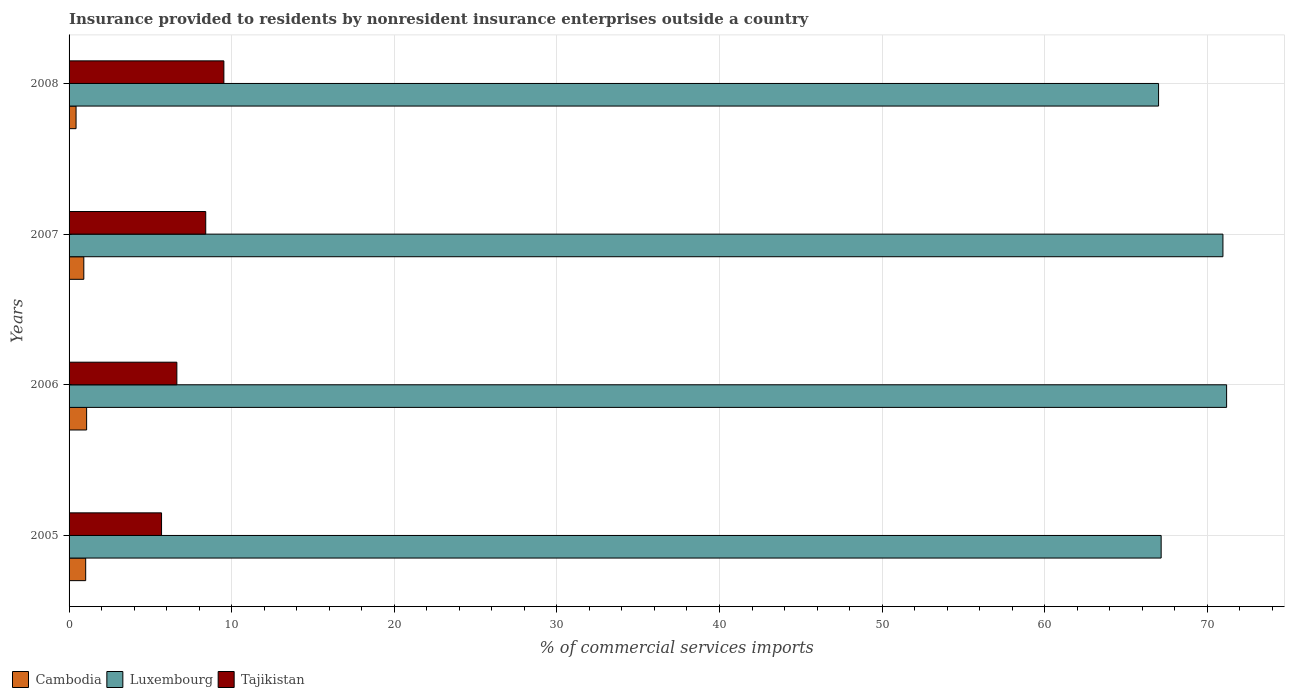How many groups of bars are there?
Your answer should be very brief. 4. Are the number of bars per tick equal to the number of legend labels?
Your response must be concise. Yes. Are the number of bars on each tick of the Y-axis equal?
Your answer should be very brief. Yes. How many bars are there on the 3rd tick from the top?
Offer a very short reply. 3. In how many cases, is the number of bars for a given year not equal to the number of legend labels?
Your response must be concise. 0. What is the Insurance provided to residents in Cambodia in 2005?
Offer a very short reply. 1.02. Across all years, what is the maximum Insurance provided to residents in Cambodia?
Your answer should be very brief. 1.08. Across all years, what is the minimum Insurance provided to residents in Cambodia?
Provide a short and direct response. 0.43. In which year was the Insurance provided to residents in Cambodia maximum?
Keep it short and to the point. 2006. What is the total Insurance provided to residents in Luxembourg in the graph?
Provide a short and direct response. 276.3. What is the difference between the Insurance provided to residents in Luxembourg in 2005 and that in 2007?
Keep it short and to the point. -3.8. What is the difference between the Insurance provided to residents in Luxembourg in 2005 and the Insurance provided to residents in Tajikistan in 2008?
Offer a terse response. 57.64. What is the average Insurance provided to residents in Luxembourg per year?
Provide a short and direct response. 69.08. In the year 2005, what is the difference between the Insurance provided to residents in Tajikistan and Insurance provided to residents in Cambodia?
Make the answer very short. 4.66. In how many years, is the Insurance provided to residents in Cambodia greater than 22 %?
Your answer should be very brief. 0. What is the ratio of the Insurance provided to residents in Tajikistan in 2007 to that in 2008?
Your answer should be very brief. 0.88. Is the Insurance provided to residents in Tajikistan in 2005 less than that in 2008?
Offer a terse response. Yes. What is the difference between the highest and the second highest Insurance provided to residents in Luxembourg?
Offer a terse response. 0.23. What is the difference between the highest and the lowest Insurance provided to residents in Tajikistan?
Make the answer very short. 3.83. In how many years, is the Insurance provided to residents in Cambodia greater than the average Insurance provided to residents in Cambodia taken over all years?
Keep it short and to the point. 3. What does the 2nd bar from the top in 2006 represents?
Your answer should be compact. Luxembourg. What does the 2nd bar from the bottom in 2006 represents?
Your response must be concise. Luxembourg. Is it the case that in every year, the sum of the Insurance provided to residents in Cambodia and Insurance provided to residents in Tajikistan is greater than the Insurance provided to residents in Luxembourg?
Make the answer very short. No. Are all the bars in the graph horizontal?
Offer a very short reply. Yes. Does the graph contain any zero values?
Give a very brief answer. No. Does the graph contain grids?
Your response must be concise. Yes. How many legend labels are there?
Provide a short and direct response. 3. How are the legend labels stacked?
Offer a terse response. Horizontal. What is the title of the graph?
Give a very brief answer. Insurance provided to residents by nonresident insurance enterprises outside a country. Does "El Salvador" appear as one of the legend labels in the graph?
Keep it short and to the point. No. What is the label or title of the X-axis?
Offer a very short reply. % of commercial services imports. What is the label or title of the Y-axis?
Keep it short and to the point. Years. What is the % of commercial services imports of Cambodia in 2005?
Give a very brief answer. 1.02. What is the % of commercial services imports of Luxembourg in 2005?
Ensure brevity in your answer.  67.16. What is the % of commercial services imports of Tajikistan in 2005?
Your answer should be compact. 5.69. What is the % of commercial services imports of Cambodia in 2006?
Provide a succinct answer. 1.08. What is the % of commercial services imports of Luxembourg in 2006?
Offer a very short reply. 71.19. What is the % of commercial services imports in Tajikistan in 2006?
Offer a very short reply. 6.63. What is the % of commercial services imports of Cambodia in 2007?
Keep it short and to the point. 0.91. What is the % of commercial services imports in Luxembourg in 2007?
Offer a terse response. 70.96. What is the % of commercial services imports of Tajikistan in 2007?
Provide a succinct answer. 8.4. What is the % of commercial services imports in Cambodia in 2008?
Offer a terse response. 0.43. What is the % of commercial services imports of Luxembourg in 2008?
Provide a succinct answer. 67. What is the % of commercial services imports in Tajikistan in 2008?
Keep it short and to the point. 9.52. Across all years, what is the maximum % of commercial services imports of Cambodia?
Give a very brief answer. 1.08. Across all years, what is the maximum % of commercial services imports of Luxembourg?
Provide a succinct answer. 71.19. Across all years, what is the maximum % of commercial services imports of Tajikistan?
Your response must be concise. 9.52. Across all years, what is the minimum % of commercial services imports in Cambodia?
Offer a very short reply. 0.43. Across all years, what is the minimum % of commercial services imports in Luxembourg?
Provide a succinct answer. 67. Across all years, what is the minimum % of commercial services imports in Tajikistan?
Provide a short and direct response. 5.69. What is the total % of commercial services imports of Cambodia in the graph?
Keep it short and to the point. 3.44. What is the total % of commercial services imports in Luxembourg in the graph?
Give a very brief answer. 276.3. What is the total % of commercial services imports of Tajikistan in the graph?
Your response must be concise. 30.24. What is the difference between the % of commercial services imports of Cambodia in 2005 and that in 2006?
Your answer should be very brief. -0.06. What is the difference between the % of commercial services imports of Luxembourg in 2005 and that in 2006?
Offer a terse response. -4.03. What is the difference between the % of commercial services imports in Tajikistan in 2005 and that in 2006?
Offer a terse response. -0.94. What is the difference between the % of commercial services imports of Cambodia in 2005 and that in 2007?
Ensure brevity in your answer.  0.12. What is the difference between the % of commercial services imports in Luxembourg in 2005 and that in 2007?
Keep it short and to the point. -3.8. What is the difference between the % of commercial services imports in Tajikistan in 2005 and that in 2007?
Ensure brevity in your answer.  -2.72. What is the difference between the % of commercial services imports of Cambodia in 2005 and that in 2008?
Give a very brief answer. 0.59. What is the difference between the % of commercial services imports of Luxembourg in 2005 and that in 2008?
Your response must be concise. 0.16. What is the difference between the % of commercial services imports in Tajikistan in 2005 and that in 2008?
Give a very brief answer. -3.83. What is the difference between the % of commercial services imports of Cambodia in 2006 and that in 2007?
Provide a short and direct response. 0.17. What is the difference between the % of commercial services imports in Luxembourg in 2006 and that in 2007?
Give a very brief answer. 0.23. What is the difference between the % of commercial services imports in Tajikistan in 2006 and that in 2007?
Your answer should be very brief. -1.78. What is the difference between the % of commercial services imports of Cambodia in 2006 and that in 2008?
Keep it short and to the point. 0.65. What is the difference between the % of commercial services imports of Luxembourg in 2006 and that in 2008?
Keep it short and to the point. 4.19. What is the difference between the % of commercial services imports in Tajikistan in 2006 and that in 2008?
Keep it short and to the point. -2.89. What is the difference between the % of commercial services imports of Cambodia in 2007 and that in 2008?
Give a very brief answer. 0.48. What is the difference between the % of commercial services imports of Luxembourg in 2007 and that in 2008?
Your response must be concise. 3.96. What is the difference between the % of commercial services imports in Tajikistan in 2007 and that in 2008?
Offer a terse response. -1.12. What is the difference between the % of commercial services imports in Cambodia in 2005 and the % of commercial services imports in Luxembourg in 2006?
Provide a succinct answer. -70.16. What is the difference between the % of commercial services imports in Cambodia in 2005 and the % of commercial services imports in Tajikistan in 2006?
Give a very brief answer. -5.61. What is the difference between the % of commercial services imports in Luxembourg in 2005 and the % of commercial services imports in Tajikistan in 2006?
Your answer should be compact. 60.53. What is the difference between the % of commercial services imports of Cambodia in 2005 and the % of commercial services imports of Luxembourg in 2007?
Your answer should be very brief. -69.94. What is the difference between the % of commercial services imports in Cambodia in 2005 and the % of commercial services imports in Tajikistan in 2007?
Give a very brief answer. -7.38. What is the difference between the % of commercial services imports in Luxembourg in 2005 and the % of commercial services imports in Tajikistan in 2007?
Your response must be concise. 58.76. What is the difference between the % of commercial services imports of Cambodia in 2005 and the % of commercial services imports of Luxembourg in 2008?
Provide a short and direct response. -65.98. What is the difference between the % of commercial services imports of Cambodia in 2005 and the % of commercial services imports of Tajikistan in 2008?
Offer a terse response. -8.5. What is the difference between the % of commercial services imports in Luxembourg in 2005 and the % of commercial services imports in Tajikistan in 2008?
Your response must be concise. 57.64. What is the difference between the % of commercial services imports in Cambodia in 2006 and the % of commercial services imports in Luxembourg in 2007?
Your answer should be compact. -69.88. What is the difference between the % of commercial services imports in Cambodia in 2006 and the % of commercial services imports in Tajikistan in 2007?
Ensure brevity in your answer.  -7.32. What is the difference between the % of commercial services imports in Luxembourg in 2006 and the % of commercial services imports in Tajikistan in 2007?
Your response must be concise. 62.78. What is the difference between the % of commercial services imports in Cambodia in 2006 and the % of commercial services imports in Luxembourg in 2008?
Your response must be concise. -65.92. What is the difference between the % of commercial services imports in Cambodia in 2006 and the % of commercial services imports in Tajikistan in 2008?
Offer a very short reply. -8.44. What is the difference between the % of commercial services imports of Luxembourg in 2006 and the % of commercial services imports of Tajikistan in 2008?
Make the answer very short. 61.67. What is the difference between the % of commercial services imports in Cambodia in 2007 and the % of commercial services imports in Luxembourg in 2008?
Offer a terse response. -66.09. What is the difference between the % of commercial services imports of Cambodia in 2007 and the % of commercial services imports of Tajikistan in 2008?
Offer a terse response. -8.61. What is the difference between the % of commercial services imports of Luxembourg in 2007 and the % of commercial services imports of Tajikistan in 2008?
Give a very brief answer. 61.44. What is the average % of commercial services imports in Cambodia per year?
Provide a succinct answer. 0.86. What is the average % of commercial services imports in Luxembourg per year?
Your answer should be very brief. 69.08. What is the average % of commercial services imports in Tajikistan per year?
Make the answer very short. 7.56. In the year 2005, what is the difference between the % of commercial services imports in Cambodia and % of commercial services imports in Luxembourg?
Offer a terse response. -66.14. In the year 2005, what is the difference between the % of commercial services imports in Cambodia and % of commercial services imports in Tajikistan?
Ensure brevity in your answer.  -4.66. In the year 2005, what is the difference between the % of commercial services imports of Luxembourg and % of commercial services imports of Tajikistan?
Offer a terse response. 61.47. In the year 2006, what is the difference between the % of commercial services imports in Cambodia and % of commercial services imports in Luxembourg?
Your answer should be compact. -70.11. In the year 2006, what is the difference between the % of commercial services imports in Cambodia and % of commercial services imports in Tajikistan?
Offer a terse response. -5.55. In the year 2006, what is the difference between the % of commercial services imports in Luxembourg and % of commercial services imports in Tajikistan?
Keep it short and to the point. 64.56. In the year 2007, what is the difference between the % of commercial services imports in Cambodia and % of commercial services imports in Luxembourg?
Provide a short and direct response. -70.05. In the year 2007, what is the difference between the % of commercial services imports in Cambodia and % of commercial services imports in Tajikistan?
Provide a short and direct response. -7.5. In the year 2007, what is the difference between the % of commercial services imports in Luxembourg and % of commercial services imports in Tajikistan?
Offer a very short reply. 62.55. In the year 2008, what is the difference between the % of commercial services imports in Cambodia and % of commercial services imports in Luxembourg?
Make the answer very short. -66.57. In the year 2008, what is the difference between the % of commercial services imports in Cambodia and % of commercial services imports in Tajikistan?
Keep it short and to the point. -9.09. In the year 2008, what is the difference between the % of commercial services imports of Luxembourg and % of commercial services imports of Tajikistan?
Your response must be concise. 57.48. What is the ratio of the % of commercial services imports of Cambodia in 2005 to that in 2006?
Your answer should be very brief. 0.95. What is the ratio of the % of commercial services imports in Luxembourg in 2005 to that in 2006?
Make the answer very short. 0.94. What is the ratio of the % of commercial services imports of Tajikistan in 2005 to that in 2006?
Make the answer very short. 0.86. What is the ratio of the % of commercial services imports in Cambodia in 2005 to that in 2007?
Give a very brief answer. 1.13. What is the ratio of the % of commercial services imports of Luxembourg in 2005 to that in 2007?
Provide a short and direct response. 0.95. What is the ratio of the % of commercial services imports of Tajikistan in 2005 to that in 2007?
Provide a succinct answer. 0.68. What is the ratio of the % of commercial services imports in Cambodia in 2005 to that in 2008?
Provide a short and direct response. 2.38. What is the ratio of the % of commercial services imports in Luxembourg in 2005 to that in 2008?
Your response must be concise. 1. What is the ratio of the % of commercial services imports in Tajikistan in 2005 to that in 2008?
Offer a very short reply. 0.6. What is the ratio of the % of commercial services imports in Cambodia in 2006 to that in 2007?
Your response must be concise. 1.19. What is the ratio of the % of commercial services imports in Luxembourg in 2006 to that in 2007?
Ensure brevity in your answer.  1. What is the ratio of the % of commercial services imports of Tajikistan in 2006 to that in 2007?
Offer a very short reply. 0.79. What is the ratio of the % of commercial services imports in Cambodia in 2006 to that in 2008?
Keep it short and to the point. 2.51. What is the ratio of the % of commercial services imports of Tajikistan in 2006 to that in 2008?
Offer a very short reply. 0.7. What is the ratio of the % of commercial services imports in Cambodia in 2007 to that in 2008?
Offer a terse response. 2.11. What is the ratio of the % of commercial services imports in Luxembourg in 2007 to that in 2008?
Your response must be concise. 1.06. What is the ratio of the % of commercial services imports of Tajikistan in 2007 to that in 2008?
Ensure brevity in your answer.  0.88. What is the difference between the highest and the second highest % of commercial services imports in Cambodia?
Offer a terse response. 0.06. What is the difference between the highest and the second highest % of commercial services imports in Luxembourg?
Keep it short and to the point. 0.23. What is the difference between the highest and the second highest % of commercial services imports of Tajikistan?
Provide a short and direct response. 1.12. What is the difference between the highest and the lowest % of commercial services imports in Cambodia?
Your answer should be compact. 0.65. What is the difference between the highest and the lowest % of commercial services imports in Luxembourg?
Make the answer very short. 4.19. What is the difference between the highest and the lowest % of commercial services imports of Tajikistan?
Provide a succinct answer. 3.83. 